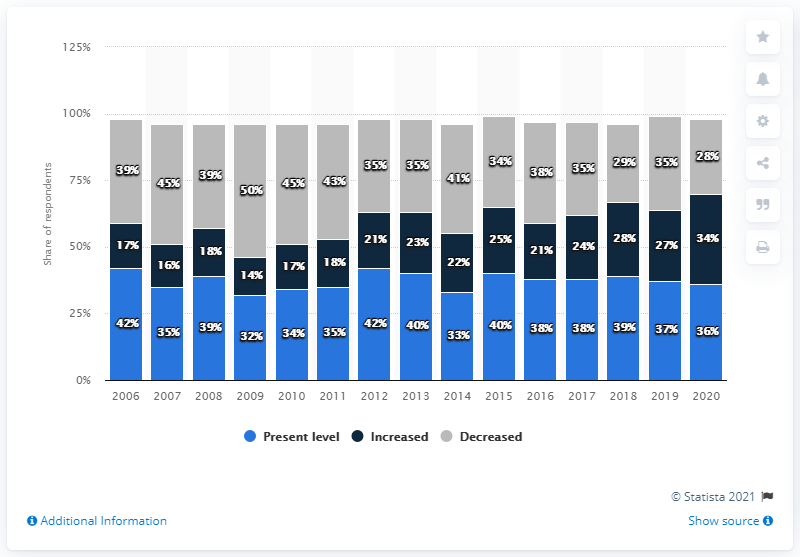Point out several critical features in this image. The survey found that 34% of respondents believed that immigration levels should remain the same in 2010. The average of all the bars in 2015 is 33. 